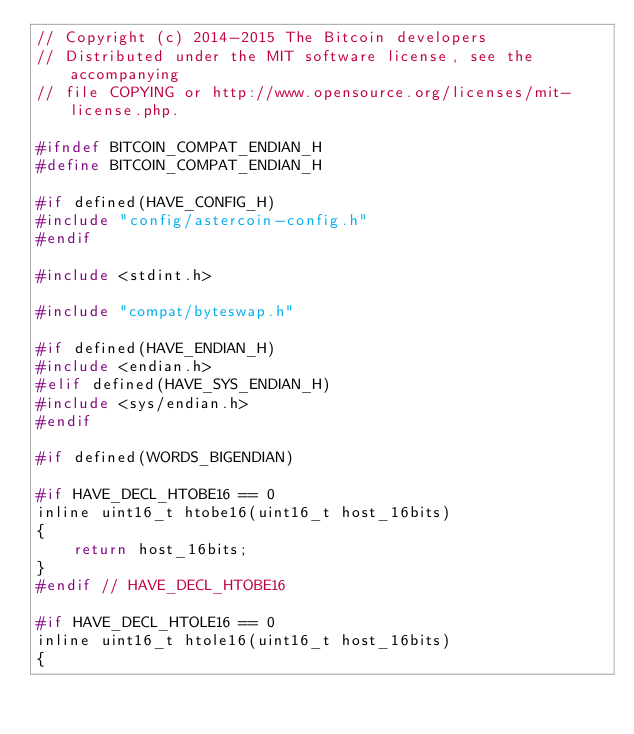Convert code to text. <code><loc_0><loc_0><loc_500><loc_500><_C_>// Copyright (c) 2014-2015 The Bitcoin developers
// Distributed under the MIT software license, see the accompanying
// file COPYING or http://www.opensource.org/licenses/mit-license.php.

#ifndef BITCOIN_COMPAT_ENDIAN_H
#define BITCOIN_COMPAT_ENDIAN_H

#if defined(HAVE_CONFIG_H)
#include "config/astercoin-config.h"
#endif

#include <stdint.h>

#include "compat/byteswap.h"

#if defined(HAVE_ENDIAN_H)
#include <endian.h>
#elif defined(HAVE_SYS_ENDIAN_H)
#include <sys/endian.h>
#endif

#if defined(WORDS_BIGENDIAN)

#if HAVE_DECL_HTOBE16 == 0
inline uint16_t htobe16(uint16_t host_16bits)
{
    return host_16bits;
}
#endif // HAVE_DECL_HTOBE16

#if HAVE_DECL_HTOLE16 == 0
inline uint16_t htole16(uint16_t host_16bits)
{</code> 